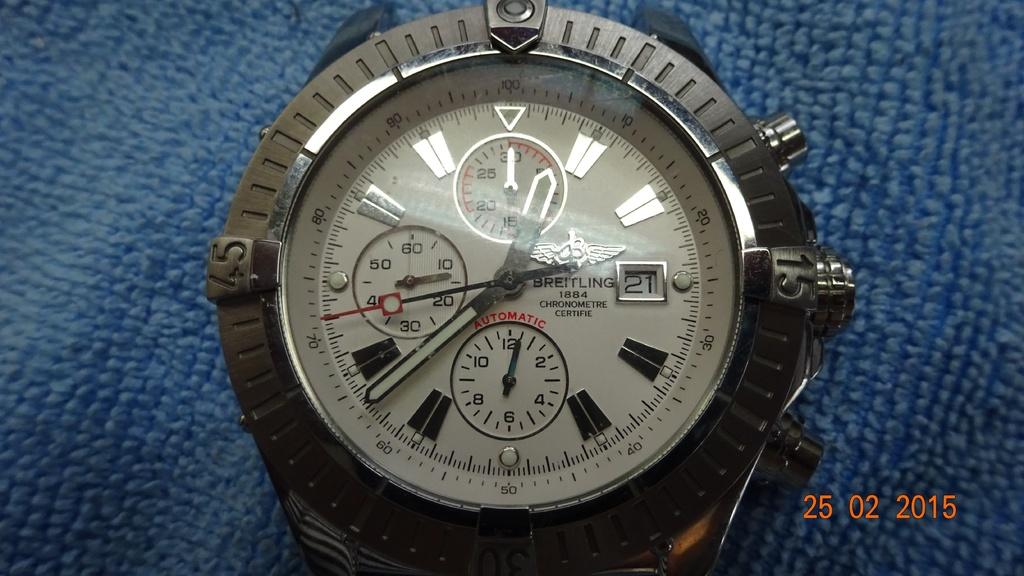What do the red letters on the watch face spell out?
Provide a succinct answer. Automatic. What time is it on the watch?
Your answer should be very brief. 12:38. 